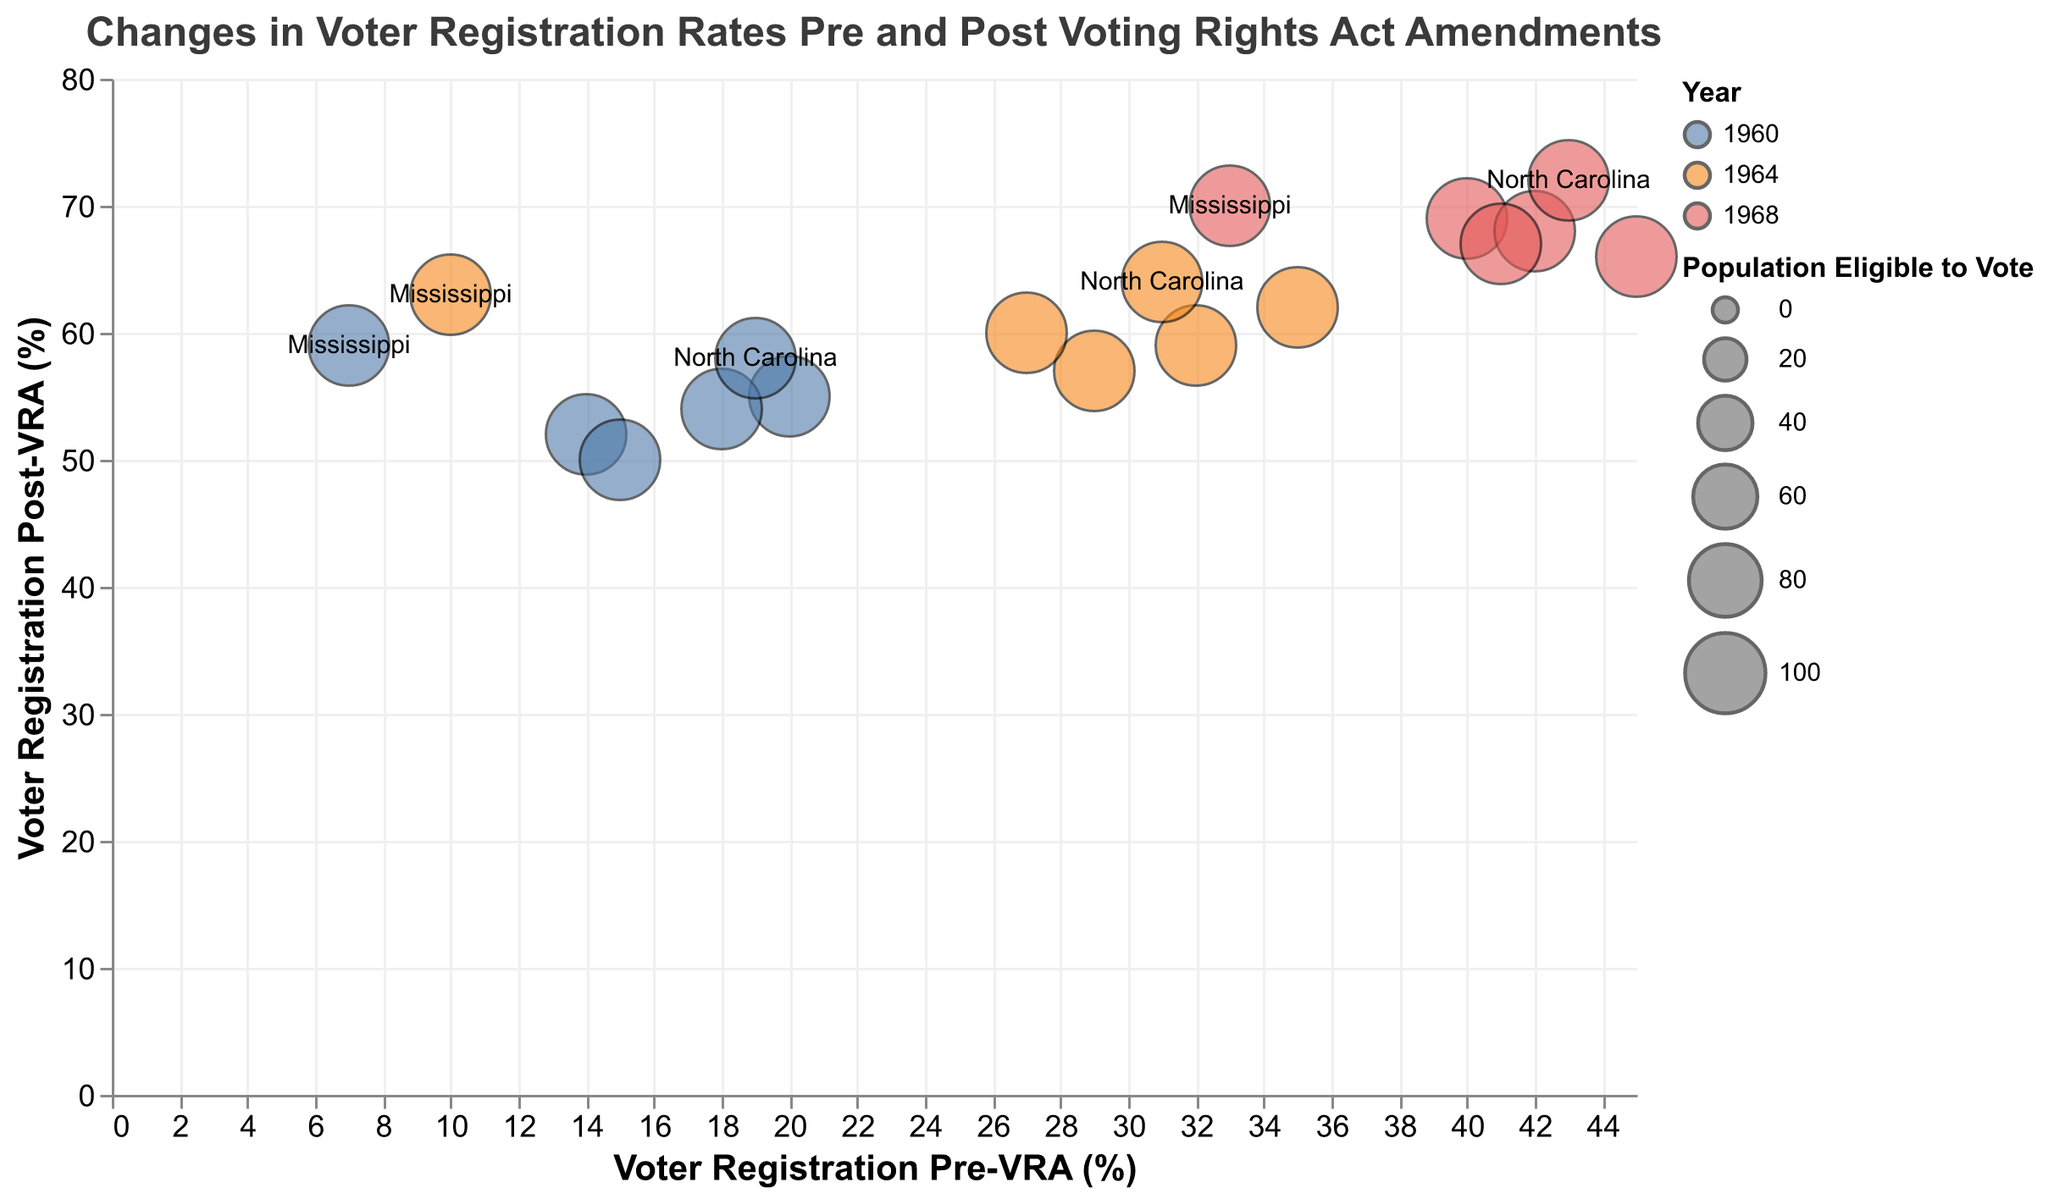What is the title of the figure? The title is typically displayed at the top of the figure, providing a summary of what the chart represents.
Answer: Changes in Voter Registration Rates Pre and Post Voting Rights Act Amendments What is the x-axis labeled as? The x-axis label is located at the bottom of the chart and describes what the horizontal axis represents.
Answer: Voter Registration Pre-VRA (%) Which state had the lowest voter registration rate pre-VRA in 1960? By looking at the data points around the lower end of the x-axis at "1960" and finding the state name nearby, we see that Mississippi has the lowest pre-VRA rate.
Answer: Mississippi How many states are represented in the dataset? Each bubble's label corresponds to a unique state. Count the distinct state labels present in the chart.
Answer: 6 Which year has the highest overall post-VRA voter registration rates? Compare the y-axis values associated with each year, and find the year with the top-most positioning of bubbles.
Answer: 1968 What is the average increase in voter registration in Alabama from 1960 to 1968? Calculate the increase for each pair of years by subtracting the pre-VRA value from the post-VRA value for Alabama, then average these increases.
Answer: 31 What region do all represented states belong to? Identify the common region attribute associated with each state, which is mentioned either in the chart or data table.
Answer: Southern Which state showed the most significant change in post-VRA voter registration rates between 1960 and 1964? By observing the y-axis values and tooltip data for 1960 and 1964, identify the state with the largest increase when moving upwards from 1960 to 1964.
Answer: Mississippi How are the bubbles differentiated by year in the bubble chart? Examine the chart to see how years are color-coded or labeled distinctly to allow differentiation.
Answer: By color Which state has a visible tooltip regardless of its transparency condition? By reading the encoding logic or examining the chart for constant tooltips, identify states like Mississippi and North Carolina, which don't follow opacity conditions.
Answer: Mississippi/North Carolina 